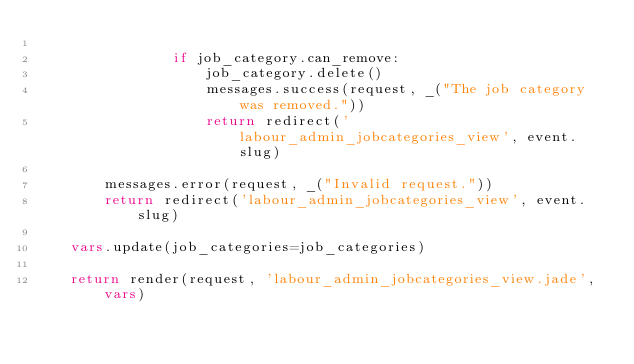Convert code to text. <code><loc_0><loc_0><loc_500><loc_500><_Python_>
                if job_category.can_remove:
                    job_category.delete()
                    messages.success(request, _("The job category was removed."))
                    return redirect('labour_admin_jobcategories_view', event.slug)

        messages.error(request, _("Invalid request."))
        return redirect('labour_admin_jobcategories_view', event.slug)

    vars.update(job_categories=job_categories)

    return render(request, 'labour_admin_jobcategories_view.jade', vars)</code> 